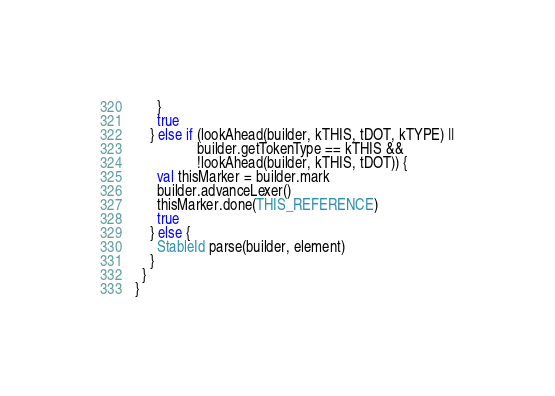Convert code to text. <code><loc_0><loc_0><loc_500><loc_500><_Scala_>      }
      true
    } else if (lookAhead(builder, kTHIS, tDOT, kTYPE) ||
                 builder.getTokenType == kTHIS &&
                 !lookAhead(builder, kTHIS, tDOT)) {
      val thisMarker = builder.mark
      builder.advanceLexer()
      thisMarker.done(THIS_REFERENCE)
      true
    } else {
      StableId parse(builder, element)
    }
  }
}</code> 